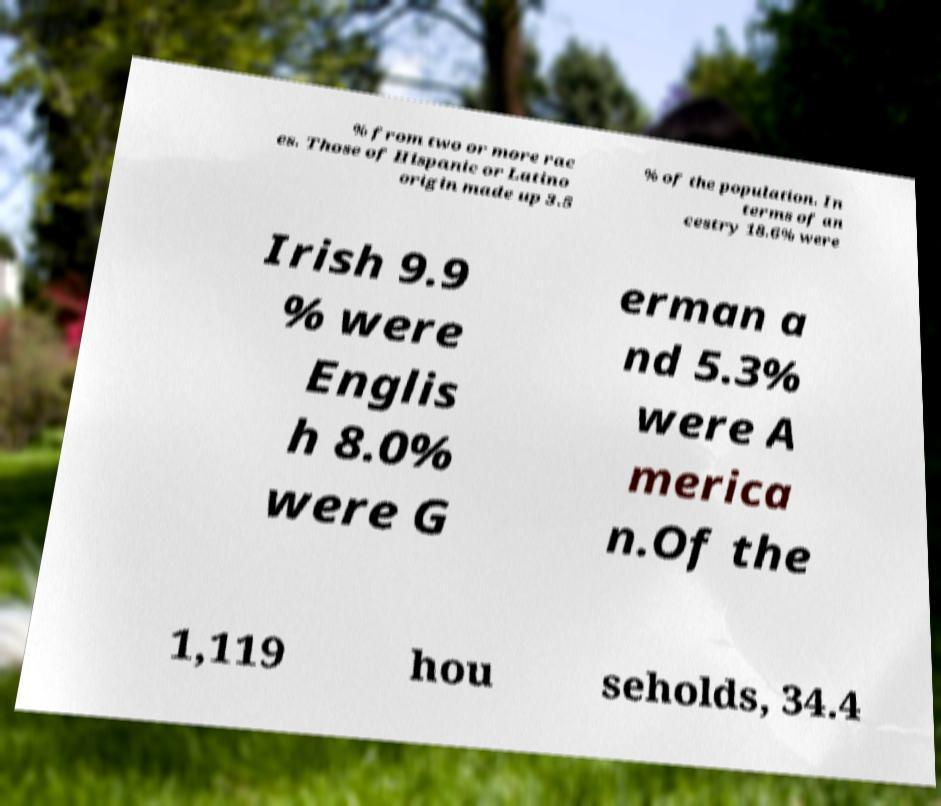Can you read and provide the text displayed in the image?This photo seems to have some interesting text. Can you extract and type it out for me? % from two or more rac es. Those of Hispanic or Latino origin made up 3.5 % of the population. In terms of an cestry 18.6% were Irish 9.9 % were Englis h 8.0% were G erman a nd 5.3% were A merica n.Of the 1,119 hou seholds, 34.4 